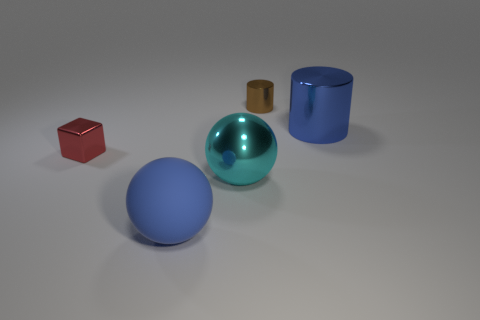Is there any other thing that is the same material as the blue ball?
Provide a short and direct response. No. There is another shiny thing that is the same shape as the brown shiny thing; what size is it?
Provide a short and direct response. Large. There is a red metal block; is its size the same as the cylinder in front of the small cylinder?
Provide a short and direct response. No. Is there a small brown thing that is in front of the large thing behind the tiny red metal cube?
Keep it short and to the point. No. There is a blue object in front of the big blue cylinder; what shape is it?
Make the answer very short. Sphere. There is a cylinder that is the same color as the big matte ball; what material is it?
Offer a very short reply. Metal. There is a tiny object that is in front of the big thing that is behind the small cube; what color is it?
Provide a short and direct response. Red. Do the metallic cube and the cyan shiny object have the same size?
Provide a short and direct response. No. There is a large object that is the same shape as the tiny brown thing; what is its material?
Make the answer very short. Metal. How many metal blocks have the same size as the cyan thing?
Offer a very short reply. 0. 